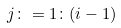Convert formula to latex. <formula><loc_0><loc_0><loc_500><loc_500>j \colon = 1 \colon ( i - 1 )</formula> 